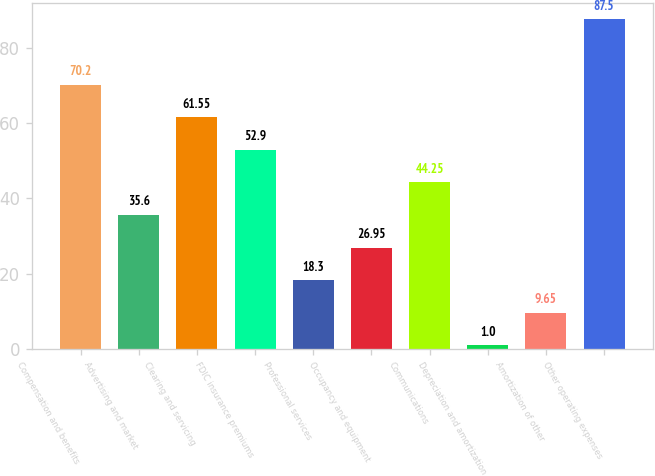Convert chart. <chart><loc_0><loc_0><loc_500><loc_500><bar_chart><fcel>Compensation and benefits<fcel>Advertising and market<fcel>Clearing and servicing<fcel>FDIC insurance premiums<fcel>Professional services<fcel>Occupancy and equipment<fcel>Communications<fcel>Depreciation and amortization<fcel>Amortization of other<fcel>Other operating expenses<nl><fcel>70.2<fcel>35.6<fcel>61.55<fcel>52.9<fcel>18.3<fcel>26.95<fcel>44.25<fcel>1<fcel>9.65<fcel>87.5<nl></chart> 